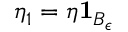<formula> <loc_0><loc_0><loc_500><loc_500>\eta _ { 1 } = \eta 1 _ { B _ { \epsilon } }</formula> 